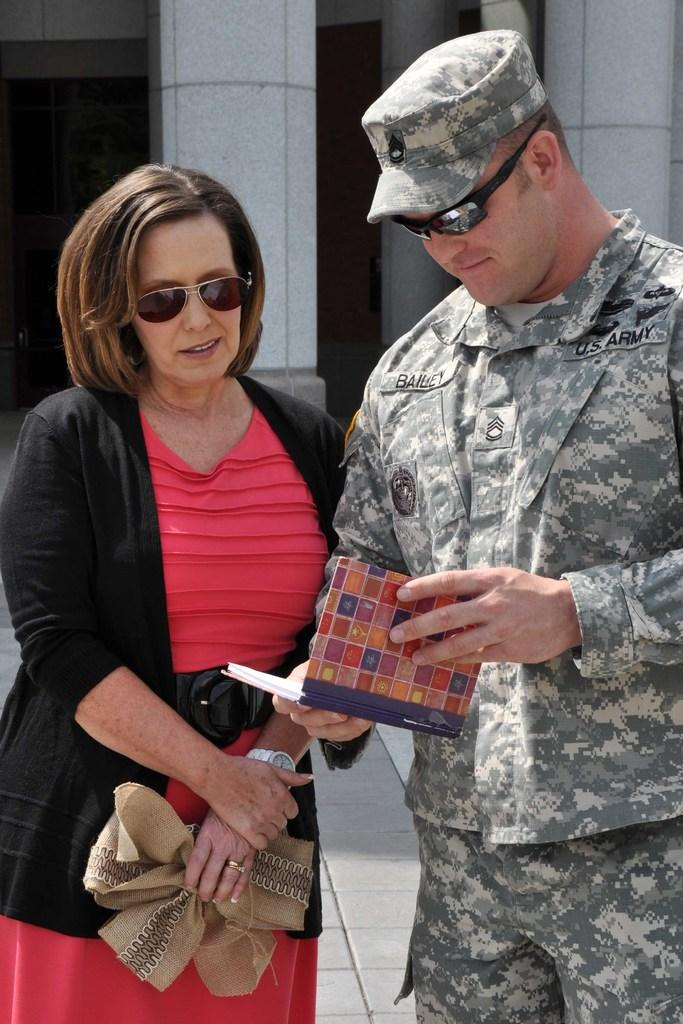What is the man in the image wearing? The man is wearing goggles and an army dress. What is the man holding in the image? The man is holding a book. What is the woman in the image wearing? The woman is wearing goggles and a jacket. What can be seen in the background of the image? There are pillars in the background of the image. How many pigs are visible in the image? There are no pigs present in the image. What type of cloth is the woman using to clean the rake in the image? There is no rake or cloth present in the image. 